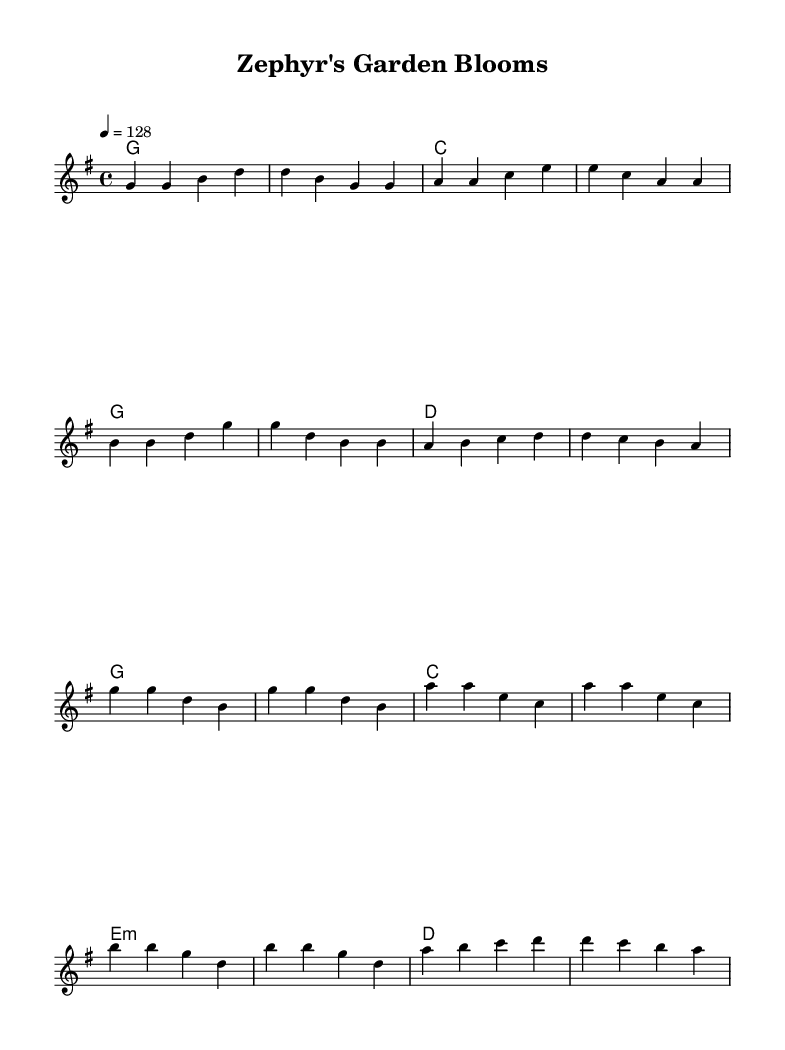What is the key signature of this music? The key signature is G major, which has one sharp (F#). This can be identified by looking at the key signature at the beginning of the staff.
Answer: G major What is the time signature of this music? The time signature is 4/4, indicated at the start of the sheet music, which tells you that there are four beats per measure.
Answer: 4/4 What is the tempo marking for this music? The tempo marking shows a speed of 128 beats per minute indicated by the notation "4 = 128," which denotes the tempo of the piece.
Answer: 128 How many measures are there in the verse? The verse section contains a total of 8 measures as indicated by counting each set of musical notes between the vertical bar lines.
Answer: 8 What is the primary chord used in the chorus? The primary chord used in the chorus is G major, as denoted by the chord symbols above the melody throughout the chorus section.
Answer: G Does this piece follow a typical structure of a country rock anthem? Yes, the piece follows a typical structure with clearly defined verse and chorus sections, which is characteristic of country rock anthems.
Answer: Yes What type of lyrics would likely complement the melody of this music? The melody, being upbeat and celebratory, would likely be complemented by lyrics that celebrate the beauty of botanical gardens or nature.
Answer: Celebratory lyrics 